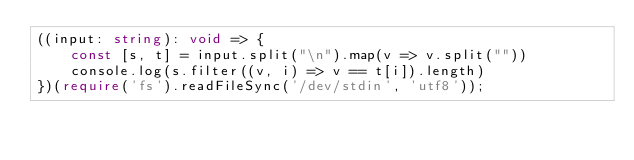<code> <loc_0><loc_0><loc_500><loc_500><_TypeScript_>((input: string): void => {
    const [s, t] = input.split("\n").map(v => v.split(""))
    console.log(s.filter((v, i) => v == t[i]).length)
})(require('fs').readFileSync('/dev/stdin', 'utf8'));
</code> 